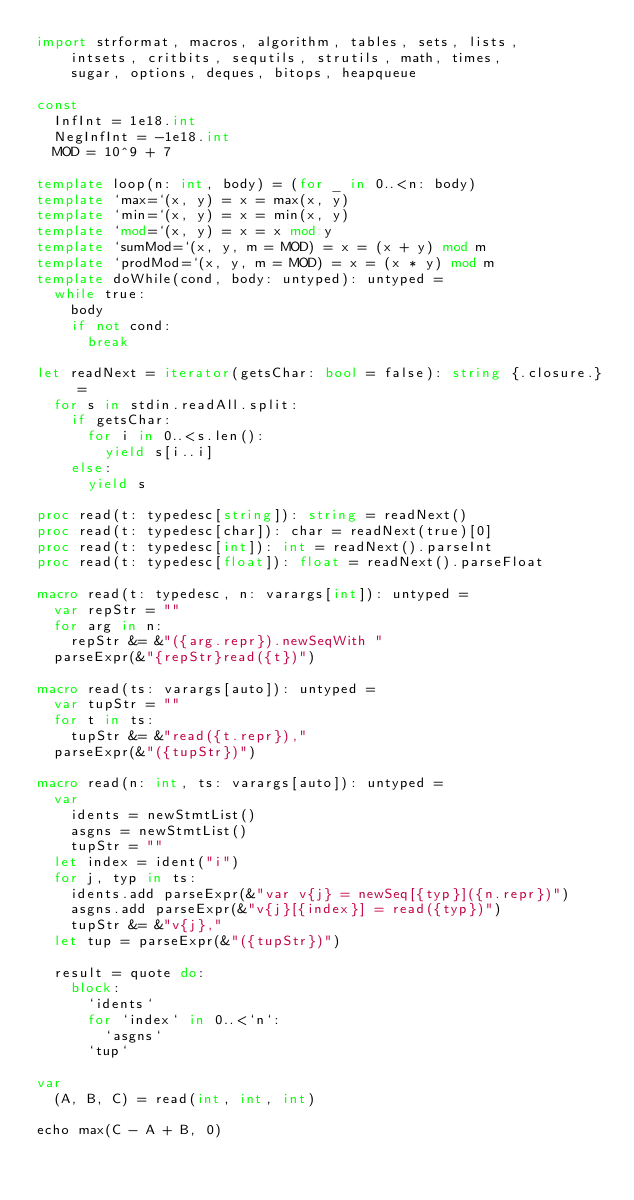Convert code to text. <code><loc_0><loc_0><loc_500><loc_500><_Nim_>import strformat, macros, algorithm, tables, sets, lists,
    intsets, critbits, sequtils, strutils, math, times,
    sugar, options, deques, bitops, heapqueue

const
  InfInt = 1e18.int
  NegInfInt = -1e18.int
  MOD = 10^9 + 7

template loop(n: int, body) = (for _ in 0..<n: body)
template `max=`(x, y) = x = max(x, y)
template `min=`(x, y) = x = min(x, y)
template `mod=`(x, y) = x = x mod y
template `sumMod=`(x, y, m = MOD) = x = (x + y) mod m
template `prodMod=`(x, y, m = MOD) = x = (x * y) mod m
template doWhile(cond, body: untyped): untyped =
  while true:
    body
    if not cond:
      break

let readNext = iterator(getsChar: bool = false): string {.closure.} =
  for s in stdin.readAll.split:
    if getsChar:
      for i in 0..<s.len():
        yield s[i..i]
    else:
      yield s

proc read(t: typedesc[string]): string = readNext()
proc read(t: typedesc[char]): char = readNext(true)[0]
proc read(t: typedesc[int]): int = readNext().parseInt
proc read(t: typedesc[float]): float = readNext().parseFloat

macro read(t: typedesc, n: varargs[int]): untyped =
  var repStr = ""
  for arg in n:
    repStr &= &"({arg.repr}).newSeqWith "
  parseExpr(&"{repStr}read({t})")

macro read(ts: varargs[auto]): untyped =
  var tupStr = ""
  for t in ts:
    tupStr &= &"read({t.repr}),"
  parseExpr(&"({tupStr})")

macro read(n: int, ts: varargs[auto]): untyped =
  var
    idents = newStmtList()
    asgns = newStmtList()
    tupStr = ""
  let index = ident("i")
  for j, typ in ts:
    idents.add parseExpr(&"var v{j} = newSeq[{typ}]({n.repr})")
    asgns.add parseExpr(&"v{j}[{index}] = read({typ})")
    tupStr &= &"v{j},"
  let tup = parseExpr(&"({tupStr})")

  result = quote do:
    block:
      `idents`
      for `index` in 0..<`n`:
        `asgns`
      `tup`

var
  (A, B, C) = read(int, int, int)

echo max(C - A + B, 0)
</code> 